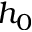Convert formula to latex. <formula><loc_0><loc_0><loc_500><loc_500>h _ { 0 }</formula> 